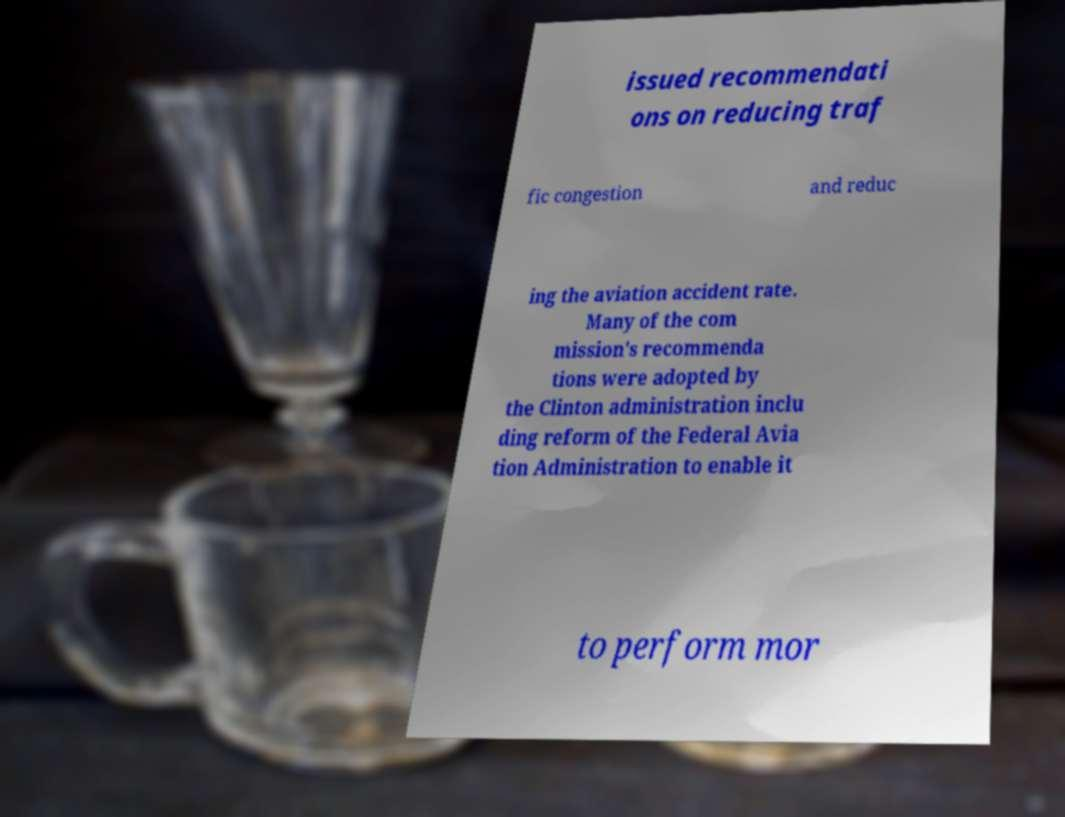I need the written content from this picture converted into text. Can you do that? issued recommendati ons on reducing traf fic congestion and reduc ing the aviation accident rate. Many of the com mission's recommenda tions were adopted by the Clinton administration inclu ding reform of the Federal Avia tion Administration to enable it to perform mor 